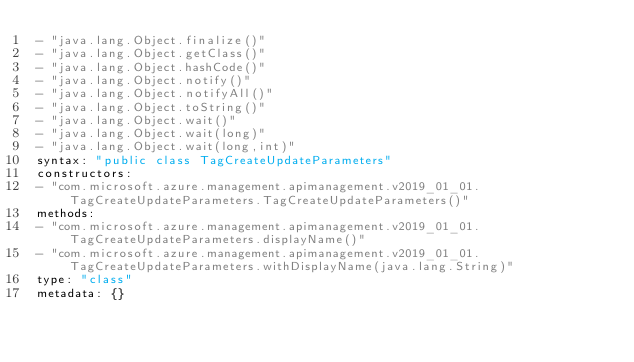<code> <loc_0><loc_0><loc_500><loc_500><_YAML_>- "java.lang.Object.finalize()"
- "java.lang.Object.getClass()"
- "java.lang.Object.hashCode()"
- "java.lang.Object.notify()"
- "java.lang.Object.notifyAll()"
- "java.lang.Object.toString()"
- "java.lang.Object.wait()"
- "java.lang.Object.wait(long)"
- "java.lang.Object.wait(long,int)"
syntax: "public class TagCreateUpdateParameters"
constructors:
- "com.microsoft.azure.management.apimanagement.v2019_01_01.TagCreateUpdateParameters.TagCreateUpdateParameters()"
methods:
- "com.microsoft.azure.management.apimanagement.v2019_01_01.TagCreateUpdateParameters.displayName()"
- "com.microsoft.azure.management.apimanagement.v2019_01_01.TagCreateUpdateParameters.withDisplayName(java.lang.String)"
type: "class"
metadata: {}</code> 